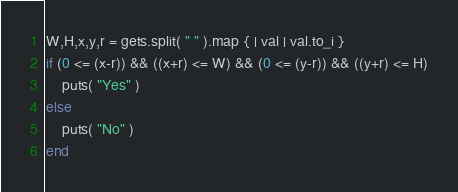Convert code to text. <code><loc_0><loc_0><loc_500><loc_500><_Ruby_>W,H,x,y,r = gets.split( " " ).map { | val | val.to_i }
if (0 <= (x-r)) && ((x+r) <= W) && (0 <= (y-r)) && ((y+r) <= H)
	puts( "Yes" )
else
	puts( "No" )
end</code> 